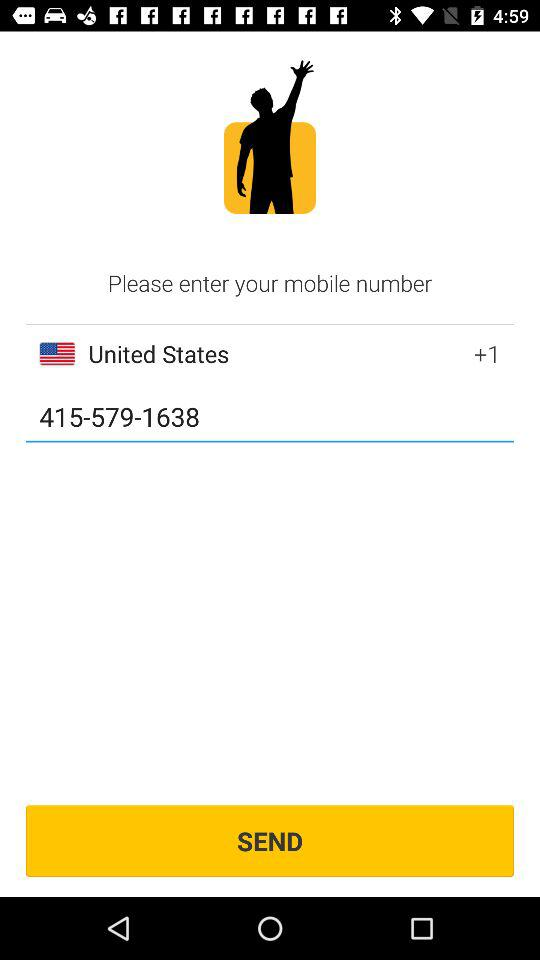How many digits are there in the mobile number?
Answer the question using a single word or phrase. 10 